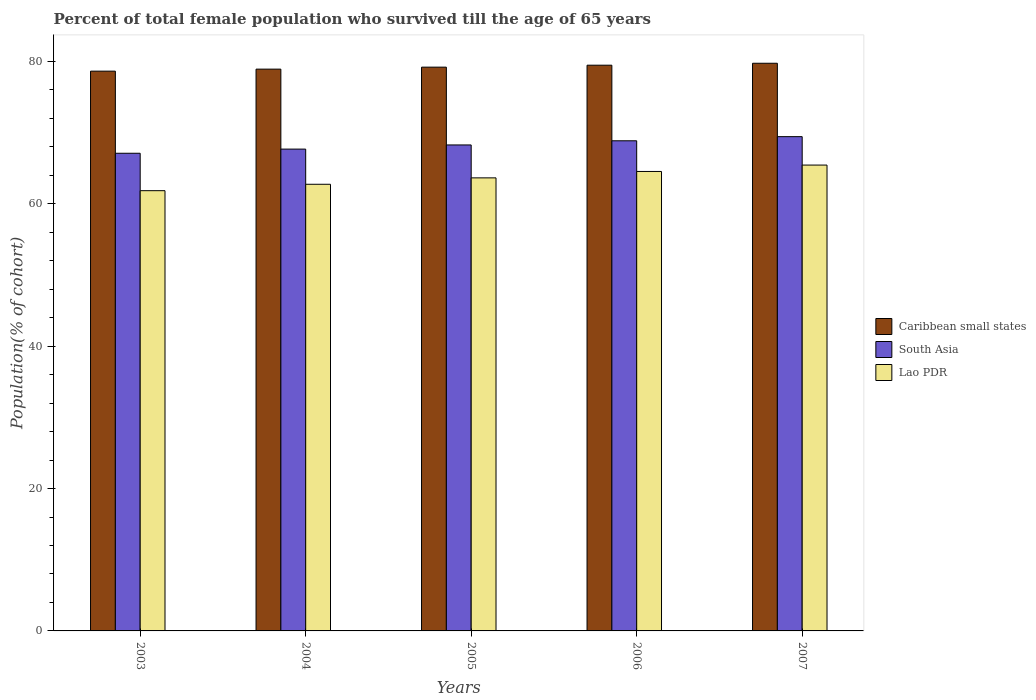How many different coloured bars are there?
Keep it short and to the point. 3. Are the number of bars per tick equal to the number of legend labels?
Ensure brevity in your answer.  Yes. Are the number of bars on each tick of the X-axis equal?
Offer a very short reply. Yes. How many bars are there on the 5th tick from the left?
Provide a succinct answer. 3. How many bars are there on the 2nd tick from the right?
Your answer should be very brief. 3. In how many cases, is the number of bars for a given year not equal to the number of legend labels?
Provide a short and direct response. 0. What is the percentage of total female population who survived till the age of 65 years in South Asia in 2006?
Offer a very short reply. 68.85. Across all years, what is the maximum percentage of total female population who survived till the age of 65 years in Lao PDR?
Ensure brevity in your answer.  65.44. Across all years, what is the minimum percentage of total female population who survived till the age of 65 years in Lao PDR?
Offer a very short reply. 61.84. In which year was the percentage of total female population who survived till the age of 65 years in South Asia maximum?
Give a very brief answer. 2007. What is the total percentage of total female population who survived till the age of 65 years in Lao PDR in the graph?
Ensure brevity in your answer.  318.21. What is the difference between the percentage of total female population who survived till the age of 65 years in Lao PDR in 2003 and that in 2004?
Provide a short and direct response. -0.9. What is the difference between the percentage of total female population who survived till the age of 65 years in Lao PDR in 2005 and the percentage of total female population who survived till the age of 65 years in Caribbean small states in 2004?
Your answer should be very brief. -15.27. What is the average percentage of total female population who survived till the age of 65 years in Caribbean small states per year?
Make the answer very short. 79.19. In the year 2004, what is the difference between the percentage of total female population who survived till the age of 65 years in South Asia and percentage of total female population who survived till the age of 65 years in Caribbean small states?
Offer a very short reply. -11.23. In how many years, is the percentage of total female population who survived till the age of 65 years in South Asia greater than 60 %?
Your answer should be compact. 5. What is the ratio of the percentage of total female population who survived till the age of 65 years in Lao PDR in 2006 to that in 2007?
Your response must be concise. 0.99. What is the difference between the highest and the second highest percentage of total female population who survived till the age of 65 years in Lao PDR?
Your answer should be very brief. 0.9. What is the difference between the highest and the lowest percentage of total female population who survived till the age of 65 years in Caribbean small states?
Give a very brief answer. 1.11. In how many years, is the percentage of total female population who survived till the age of 65 years in Lao PDR greater than the average percentage of total female population who survived till the age of 65 years in Lao PDR taken over all years?
Give a very brief answer. 2. What does the 3rd bar from the left in 2004 represents?
Your response must be concise. Lao PDR. What does the 3rd bar from the right in 2005 represents?
Make the answer very short. Caribbean small states. How many bars are there?
Ensure brevity in your answer.  15. Are all the bars in the graph horizontal?
Ensure brevity in your answer.  No. How many years are there in the graph?
Keep it short and to the point. 5. What is the difference between two consecutive major ticks on the Y-axis?
Offer a very short reply. 20. Does the graph contain any zero values?
Ensure brevity in your answer.  No. Does the graph contain grids?
Your response must be concise. No. How many legend labels are there?
Provide a succinct answer. 3. How are the legend labels stacked?
Your answer should be compact. Vertical. What is the title of the graph?
Give a very brief answer. Percent of total female population who survived till the age of 65 years. Does "Turks and Caicos Islands" appear as one of the legend labels in the graph?
Provide a short and direct response. No. What is the label or title of the Y-axis?
Give a very brief answer. Population(% of cohort). What is the Population(% of cohort) of Caribbean small states in 2003?
Your response must be concise. 78.63. What is the Population(% of cohort) in South Asia in 2003?
Offer a very short reply. 67.1. What is the Population(% of cohort) in Lao PDR in 2003?
Provide a short and direct response. 61.84. What is the Population(% of cohort) of Caribbean small states in 2004?
Offer a very short reply. 78.92. What is the Population(% of cohort) in South Asia in 2004?
Keep it short and to the point. 67.68. What is the Population(% of cohort) in Lao PDR in 2004?
Your answer should be very brief. 62.74. What is the Population(% of cohort) in Caribbean small states in 2005?
Make the answer very short. 79.19. What is the Population(% of cohort) of South Asia in 2005?
Offer a terse response. 68.27. What is the Population(% of cohort) of Lao PDR in 2005?
Keep it short and to the point. 63.64. What is the Population(% of cohort) in Caribbean small states in 2006?
Make the answer very short. 79.47. What is the Population(% of cohort) of South Asia in 2006?
Keep it short and to the point. 68.85. What is the Population(% of cohort) of Lao PDR in 2006?
Make the answer very short. 64.54. What is the Population(% of cohort) of Caribbean small states in 2007?
Provide a short and direct response. 79.74. What is the Population(% of cohort) in South Asia in 2007?
Give a very brief answer. 69.43. What is the Population(% of cohort) in Lao PDR in 2007?
Offer a terse response. 65.44. Across all years, what is the maximum Population(% of cohort) in Caribbean small states?
Give a very brief answer. 79.74. Across all years, what is the maximum Population(% of cohort) in South Asia?
Your answer should be compact. 69.43. Across all years, what is the maximum Population(% of cohort) in Lao PDR?
Provide a succinct answer. 65.44. Across all years, what is the minimum Population(% of cohort) in Caribbean small states?
Your answer should be very brief. 78.63. Across all years, what is the minimum Population(% of cohort) of South Asia?
Offer a very short reply. 67.1. Across all years, what is the minimum Population(% of cohort) of Lao PDR?
Offer a terse response. 61.84. What is the total Population(% of cohort) in Caribbean small states in the graph?
Offer a very short reply. 395.96. What is the total Population(% of cohort) in South Asia in the graph?
Make the answer very short. 341.34. What is the total Population(% of cohort) in Lao PDR in the graph?
Your answer should be compact. 318.21. What is the difference between the Population(% of cohort) in Caribbean small states in 2003 and that in 2004?
Offer a very short reply. -0.28. What is the difference between the Population(% of cohort) of South Asia in 2003 and that in 2004?
Your answer should be compact. -0.58. What is the difference between the Population(% of cohort) of Lao PDR in 2003 and that in 2004?
Offer a very short reply. -0.9. What is the difference between the Population(% of cohort) of Caribbean small states in 2003 and that in 2005?
Make the answer very short. -0.56. What is the difference between the Population(% of cohort) of South Asia in 2003 and that in 2005?
Give a very brief answer. -1.17. What is the difference between the Population(% of cohort) in Lao PDR in 2003 and that in 2005?
Offer a very short reply. -1.8. What is the difference between the Population(% of cohort) of Caribbean small states in 2003 and that in 2006?
Keep it short and to the point. -0.84. What is the difference between the Population(% of cohort) in South Asia in 2003 and that in 2006?
Offer a very short reply. -1.75. What is the difference between the Population(% of cohort) of Lao PDR in 2003 and that in 2006?
Offer a terse response. -2.7. What is the difference between the Population(% of cohort) in Caribbean small states in 2003 and that in 2007?
Provide a succinct answer. -1.11. What is the difference between the Population(% of cohort) of South Asia in 2003 and that in 2007?
Your response must be concise. -2.33. What is the difference between the Population(% of cohort) in Lao PDR in 2003 and that in 2007?
Provide a short and direct response. -3.6. What is the difference between the Population(% of cohort) of Caribbean small states in 2004 and that in 2005?
Provide a short and direct response. -0.28. What is the difference between the Population(% of cohort) of South Asia in 2004 and that in 2005?
Provide a short and direct response. -0.58. What is the difference between the Population(% of cohort) in Lao PDR in 2004 and that in 2005?
Offer a very short reply. -0.9. What is the difference between the Population(% of cohort) in Caribbean small states in 2004 and that in 2006?
Your answer should be very brief. -0.55. What is the difference between the Population(% of cohort) in South Asia in 2004 and that in 2006?
Keep it short and to the point. -1.17. What is the difference between the Population(% of cohort) of Lao PDR in 2004 and that in 2006?
Offer a terse response. -1.8. What is the difference between the Population(% of cohort) in Caribbean small states in 2004 and that in 2007?
Your answer should be compact. -0.83. What is the difference between the Population(% of cohort) in South Asia in 2004 and that in 2007?
Your answer should be compact. -1.75. What is the difference between the Population(% of cohort) of Lao PDR in 2004 and that in 2007?
Keep it short and to the point. -2.7. What is the difference between the Population(% of cohort) of Caribbean small states in 2005 and that in 2006?
Provide a succinct answer. -0.28. What is the difference between the Population(% of cohort) of South Asia in 2005 and that in 2006?
Provide a short and direct response. -0.58. What is the difference between the Population(% of cohort) in Lao PDR in 2005 and that in 2006?
Give a very brief answer. -0.9. What is the difference between the Population(% of cohort) in Caribbean small states in 2005 and that in 2007?
Your answer should be compact. -0.55. What is the difference between the Population(% of cohort) of South Asia in 2005 and that in 2007?
Your answer should be very brief. -1.17. What is the difference between the Population(% of cohort) of Lao PDR in 2005 and that in 2007?
Provide a succinct answer. -1.8. What is the difference between the Population(% of cohort) in Caribbean small states in 2006 and that in 2007?
Provide a short and direct response. -0.27. What is the difference between the Population(% of cohort) in South Asia in 2006 and that in 2007?
Offer a terse response. -0.58. What is the difference between the Population(% of cohort) in Lao PDR in 2006 and that in 2007?
Give a very brief answer. -0.9. What is the difference between the Population(% of cohort) of Caribbean small states in 2003 and the Population(% of cohort) of South Asia in 2004?
Ensure brevity in your answer.  10.95. What is the difference between the Population(% of cohort) in Caribbean small states in 2003 and the Population(% of cohort) in Lao PDR in 2004?
Provide a short and direct response. 15.89. What is the difference between the Population(% of cohort) in South Asia in 2003 and the Population(% of cohort) in Lao PDR in 2004?
Provide a succinct answer. 4.36. What is the difference between the Population(% of cohort) in Caribbean small states in 2003 and the Population(% of cohort) in South Asia in 2005?
Provide a succinct answer. 10.37. What is the difference between the Population(% of cohort) of Caribbean small states in 2003 and the Population(% of cohort) of Lao PDR in 2005?
Keep it short and to the point. 14.99. What is the difference between the Population(% of cohort) in South Asia in 2003 and the Population(% of cohort) in Lao PDR in 2005?
Ensure brevity in your answer.  3.46. What is the difference between the Population(% of cohort) of Caribbean small states in 2003 and the Population(% of cohort) of South Asia in 2006?
Offer a terse response. 9.78. What is the difference between the Population(% of cohort) in Caribbean small states in 2003 and the Population(% of cohort) in Lao PDR in 2006?
Provide a succinct answer. 14.09. What is the difference between the Population(% of cohort) in South Asia in 2003 and the Population(% of cohort) in Lao PDR in 2006?
Keep it short and to the point. 2.56. What is the difference between the Population(% of cohort) in Caribbean small states in 2003 and the Population(% of cohort) in South Asia in 2007?
Give a very brief answer. 9.2. What is the difference between the Population(% of cohort) of Caribbean small states in 2003 and the Population(% of cohort) of Lao PDR in 2007?
Offer a terse response. 13.19. What is the difference between the Population(% of cohort) of South Asia in 2003 and the Population(% of cohort) of Lao PDR in 2007?
Provide a succinct answer. 1.66. What is the difference between the Population(% of cohort) in Caribbean small states in 2004 and the Population(% of cohort) in South Asia in 2005?
Provide a short and direct response. 10.65. What is the difference between the Population(% of cohort) of Caribbean small states in 2004 and the Population(% of cohort) of Lao PDR in 2005?
Ensure brevity in your answer.  15.27. What is the difference between the Population(% of cohort) in South Asia in 2004 and the Population(% of cohort) in Lao PDR in 2005?
Your answer should be compact. 4.04. What is the difference between the Population(% of cohort) in Caribbean small states in 2004 and the Population(% of cohort) in South Asia in 2006?
Provide a short and direct response. 10.07. What is the difference between the Population(% of cohort) in Caribbean small states in 2004 and the Population(% of cohort) in Lao PDR in 2006?
Your answer should be compact. 14.37. What is the difference between the Population(% of cohort) in South Asia in 2004 and the Population(% of cohort) in Lao PDR in 2006?
Provide a short and direct response. 3.14. What is the difference between the Population(% of cohort) in Caribbean small states in 2004 and the Population(% of cohort) in South Asia in 2007?
Give a very brief answer. 9.48. What is the difference between the Population(% of cohort) of Caribbean small states in 2004 and the Population(% of cohort) of Lao PDR in 2007?
Offer a very short reply. 13.47. What is the difference between the Population(% of cohort) of South Asia in 2004 and the Population(% of cohort) of Lao PDR in 2007?
Keep it short and to the point. 2.24. What is the difference between the Population(% of cohort) of Caribbean small states in 2005 and the Population(% of cohort) of South Asia in 2006?
Your response must be concise. 10.34. What is the difference between the Population(% of cohort) in Caribbean small states in 2005 and the Population(% of cohort) in Lao PDR in 2006?
Give a very brief answer. 14.65. What is the difference between the Population(% of cohort) in South Asia in 2005 and the Population(% of cohort) in Lao PDR in 2006?
Offer a terse response. 3.72. What is the difference between the Population(% of cohort) in Caribbean small states in 2005 and the Population(% of cohort) in South Asia in 2007?
Offer a very short reply. 9.76. What is the difference between the Population(% of cohort) of Caribbean small states in 2005 and the Population(% of cohort) of Lao PDR in 2007?
Provide a succinct answer. 13.75. What is the difference between the Population(% of cohort) of South Asia in 2005 and the Population(% of cohort) of Lao PDR in 2007?
Ensure brevity in your answer.  2.83. What is the difference between the Population(% of cohort) of Caribbean small states in 2006 and the Population(% of cohort) of South Asia in 2007?
Offer a very short reply. 10.04. What is the difference between the Population(% of cohort) of Caribbean small states in 2006 and the Population(% of cohort) of Lao PDR in 2007?
Offer a very short reply. 14.03. What is the difference between the Population(% of cohort) in South Asia in 2006 and the Population(% of cohort) in Lao PDR in 2007?
Make the answer very short. 3.41. What is the average Population(% of cohort) in Caribbean small states per year?
Keep it short and to the point. 79.19. What is the average Population(% of cohort) in South Asia per year?
Your answer should be compact. 68.27. What is the average Population(% of cohort) in Lao PDR per year?
Provide a succinct answer. 63.64. In the year 2003, what is the difference between the Population(% of cohort) of Caribbean small states and Population(% of cohort) of South Asia?
Make the answer very short. 11.53. In the year 2003, what is the difference between the Population(% of cohort) in Caribbean small states and Population(% of cohort) in Lao PDR?
Your answer should be compact. 16.79. In the year 2003, what is the difference between the Population(% of cohort) of South Asia and Population(% of cohort) of Lao PDR?
Offer a terse response. 5.26. In the year 2004, what is the difference between the Population(% of cohort) of Caribbean small states and Population(% of cohort) of South Asia?
Provide a short and direct response. 11.23. In the year 2004, what is the difference between the Population(% of cohort) of Caribbean small states and Population(% of cohort) of Lao PDR?
Give a very brief answer. 16.17. In the year 2004, what is the difference between the Population(% of cohort) in South Asia and Population(% of cohort) in Lao PDR?
Provide a succinct answer. 4.94. In the year 2005, what is the difference between the Population(% of cohort) in Caribbean small states and Population(% of cohort) in South Asia?
Offer a terse response. 10.93. In the year 2005, what is the difference between the Population(% of cohort) of Caribbean small states and Population(% of cohort) of Lao PDR?
Your answer should be very brief. 15.55. In the year 2005, what is the difference between the Population(% of cohort) of South Asia and Population(% of cohort) of Lao PDR?
Make the answer very short. 4.62. In the year 2006, what is the difference between the Population(% of cohort) in Caribbean small states and Population(% of cohort) in South Asia?
Your response must be concise. 10.62. In the year 2006, what is the difference between the Population(% of cohort) of Caribbean small states and Population(% of cohort) of Lao PDR?
Keep it short and to the point. 14.93. In the year 2006, what is the difference between the Population(% of cohort) in South Asia and Population(% of cohort) in Lao PDR?
Provide a short and direct response. 4.31. In the year 2007, what is the difference between the Population(% of cohort) of Caribbean small states and Population(% of cohort) of South Asia?
Your answer should be compact. 10.31. In the year 2007, what is the difference between the Population(% of cohort) in Caribbean small states and Population(% of cohort) in Lao PDR?
Provide a succinct answer. 14.3. In the year 2007, what is the difference between the Population(% of cohort) of South Asia and Population(% of cohort) of Lao PDR?
Offer a very short reply. 3.99. What is the ratio of the Population(% of cohort) of South Asia in 2003 to that in 2004?
Your answer should be compact. 0.99. What is the ratio of the Population(% of cohort) of Lao PDR in 2003 to that in 2004?
Offer a terse response. 0.99. What is the ratio of the Population(% of cohort) in Caribbean small states in 2003 to that in 2005?
Offer a terse response. 0.99. What is the ratio of the Population(% of cohort) in South Asia in 2003 to that in 2005?
Make the answer very short. 0.98. What is the ratio of the Population(% of cohort) of Lao PDR in 2003 to that in 2005?
Provide a short and direct response. 0.97. What is the ratio of the Population(% of cohort) in Caribbean small states in 2003 to that in 2006?
Your answer should be compact. 0.99. What is the ratio of the Population(% of cohort) of South Asia in 2003 to that in 2006?
Your answer should be compact. 0.97. What is the ratio of the Population(% of cohort) in Lao PDR in 2003 to that in 2006?
Your answer should be very brief. 0.96. What is the ratio of the Population(% of cohort) of Caribbean small states in 2003 to that in 2007?
Provide a short and direct response. 0.99. What is the ratio of the Population(% of cohort) of South Asia in 2003 to that in 2007?
Your answer should be very brief. 0.97. What is the ratio of the Population(% of cohort) in Lao PDR in 2003 to that in 2007?
Provide a short and direct response. 0.94. What is the ratio of the Population(% of cohort) of Lao PDR in 2004 to that in 2005?
Offer a very short reply. 0.99. What is the ratio of the Population(% of cohort) in South Asia in 2004 to that in 2006?
Give a very brief answer. 0.98. What is the ratio of the Population(% of cohort) of Lao PDR in 2004 to that in 2006?
Your answer should be very brief. 0.97. What is the ratio of the Population(% of cohort) of Caribbean small states in 2004 to that in 2007?
Provide a short and direct response. 0.99. What is the ratio of the Population(% of cohort) of South Asia in 2004 to that in 2007?
Make the answer very short. 0.97. What is the ratio of the Population(% of cohort) in Lao PDR in 2004 to that in 2007?
Your answer should be compact. 0.96. What is the ratio of the Population(% of cohort) of Caribbean small states in 2005 to that in 2006?
Your answer should be very brief. 1. What is the ratio of the Population(% of cohort) in Lao PDR in 2005 to that in 2006?
Your response must be concise. 0.99. What is the ratio of the Population(% of cohort) in South Asia in 2005 to that in 2007?
Keep it short and to the point. 0.98. What is the ratio of the Population(% of cohort) in Lao PDR in 2005 to that in 2007?
Your answer should be very brief. 0.97. What is the ratio of the Population(% of cohort) of Caribbean small states in 2006 to that in 2007?
Provide a succinct answer. 1. What is the ratio of the Population(% of cohort) of Lao PDR in 2006 to that in 2007?
Offer a terse response. 0.99. What is the difference between the highest and the second highest Population(% of cohort) of Caribbean small states?
Keep it short and to the point. 0.27. What is the difference between the highest and the second highest Population(% of cohort) of South Asia?
Make the answer very short. 0.58. What is the difference between the highest and the second highest Population(% of cohort) in Lao PDR?
Offer a very short reply. 0.9. What is the difference between the highest and the lowest Population(% of cohort) of Caribbean small states?
Keep it short and to the point. 1.11. What is the difference between the highest and the lowest Population(% of cohort) in South Asia?
Offer a very short reply. 2.33. What is the difference between the highest and the lowest Population(% of cohort) in Lao PDR?
Keep it short and to the point. 3.6. 